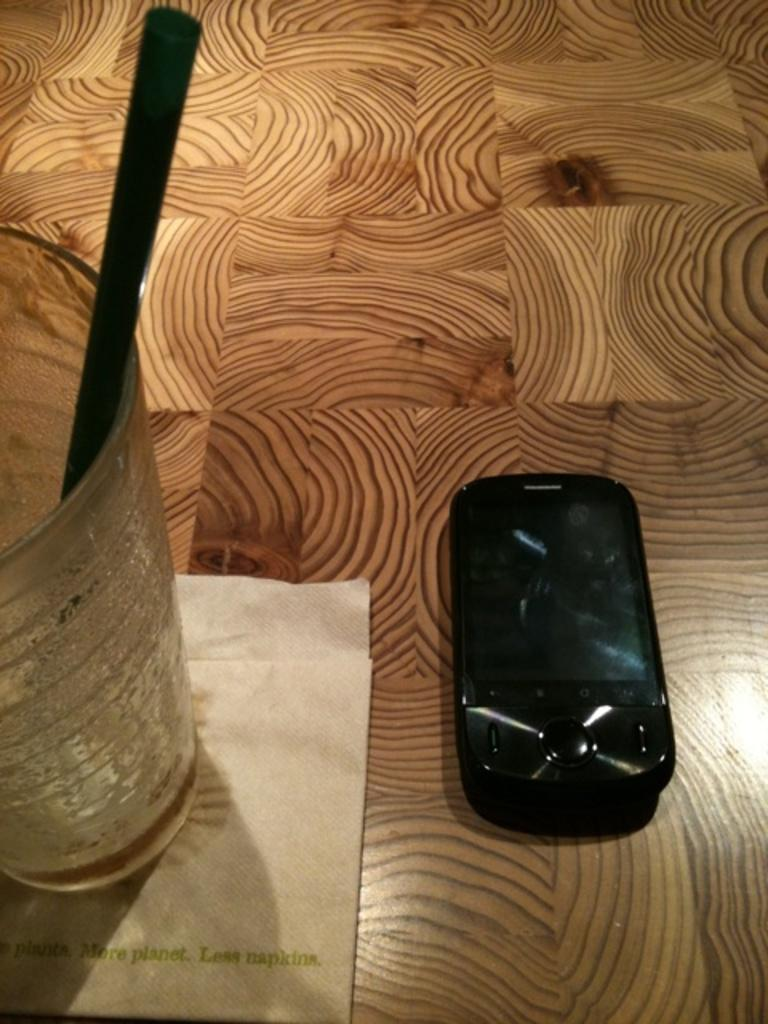<image>
Present a compact description of the photo's key features. An empty glass sitting on a napkin that says "More planet. Less napkins." 